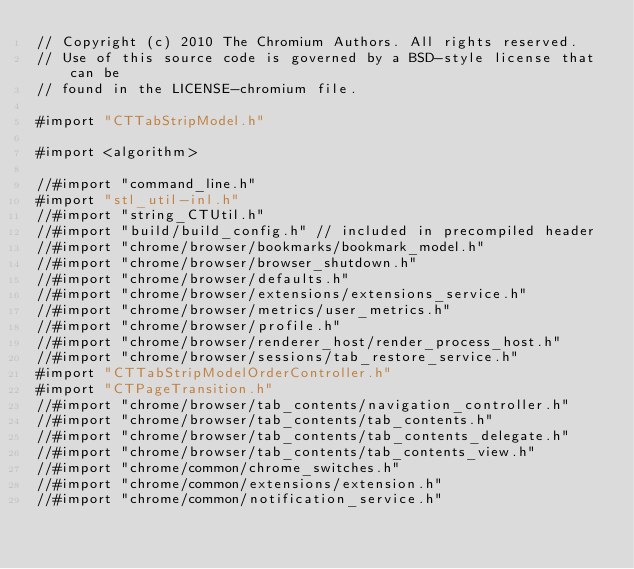<code> <loc_0><loc_0><loc_500><loc_500><_ObjectiveC_>// Copyright (c) 2010 The Chromium Authors. All rights reserved.
// Use of this source code is governed by a BSD-style license that can be
// found in the LICENSE-chromium file.

#import "CTTabStripModel.h"

#import <algorithm>

//#import "command_line.h"
#import "stl_util-inl.h"
//#import "string_CTUtil.h"
//#import "build/build_config.h" // included in precompiled header
//#import "chrome/browser/bookmarks/bookmark_model.h"
//#import "chrome/browser/browser_shutdown.h"
//#import "chrome/browser/defaults.h"
//#import "chrome/browser/extensions/extensions_service.h"
//#import "chrome/browser/metrics/user_metrics.h"
//#import "chrome/browser/profile.h"
//#import "chrome/browser/renderer_host/render_process_host.h"
//#import "chrome/browser/sessions/tab_restore_service.h"
#import "CTTabStripModelOrderController.h"
#import "CTPageTransition.h"
//#import "chrome/browser/tab_contents/navigation_controller.h"
//#import "chrome/browser/tab_contents/tab_contents.h"
//#import "chrome/browser/tab_contents/tab_contents_delegate.h"
//#import "chrome/browser/tab_contents/tab_contents_view.h"
//#import "chrome/common/chrome_switches.h"
//#import "chrome/common/extensions/extension.h"
//#import "chrome/common/notification_service.h"</code> 